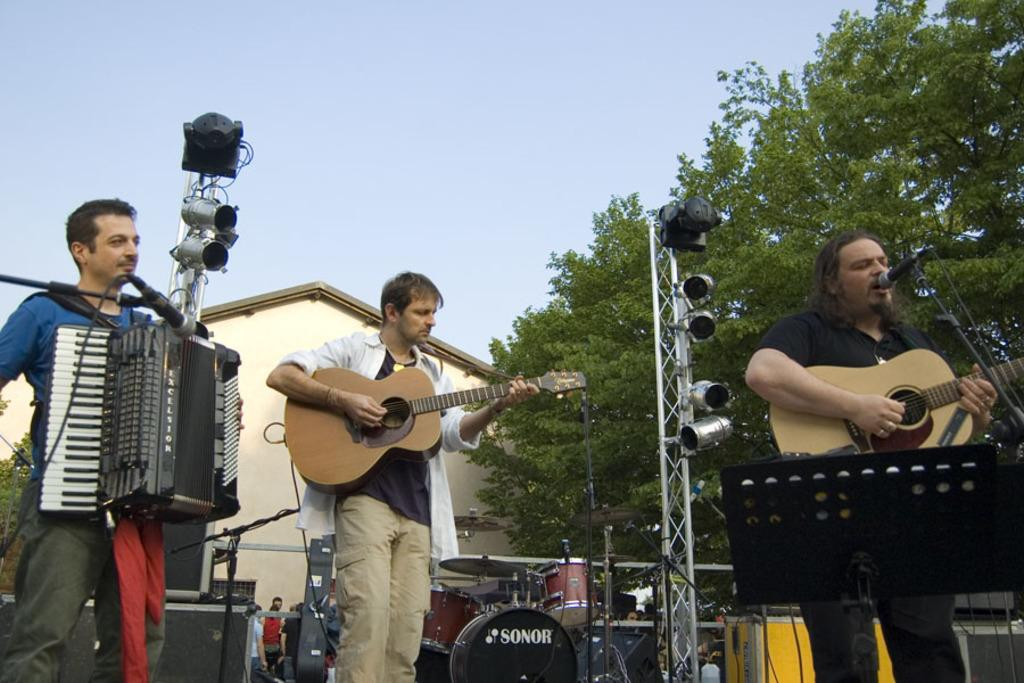How many people are in the image? There are three people in the image. What are two of the people doing in the image? Two of the people are playing guitars. What is the third person doing in the image? The third person is playing a piano. What type of vegetation can be seen in the image? There is a tree visible in the image. What type of structure is visible in the background of the image? There is a house in the background of the image. Can you tell me how many waves are visible in the image? There are no waves visible in the image; it features people playing musical instruments and a tree. What type of degree does the person playing the piano have in the image? There is no information about the person's degree in the image, as it focuses on their activity of playing the piano. 